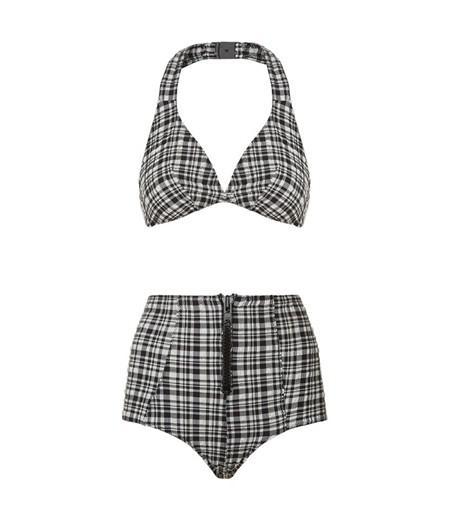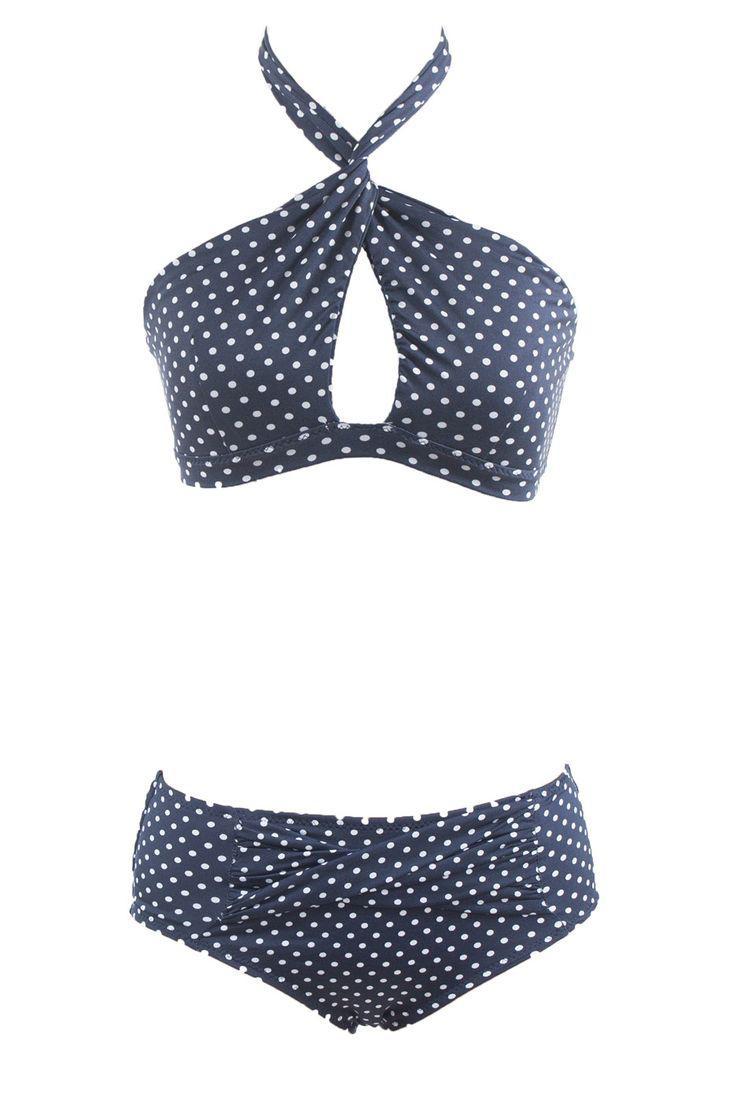The first image is the image on the left, the second image is the image on the right. Analyze the images presented: Is the assertion "One of the swimsuits has a floral pattern" valid? Answer yes or no. No. 